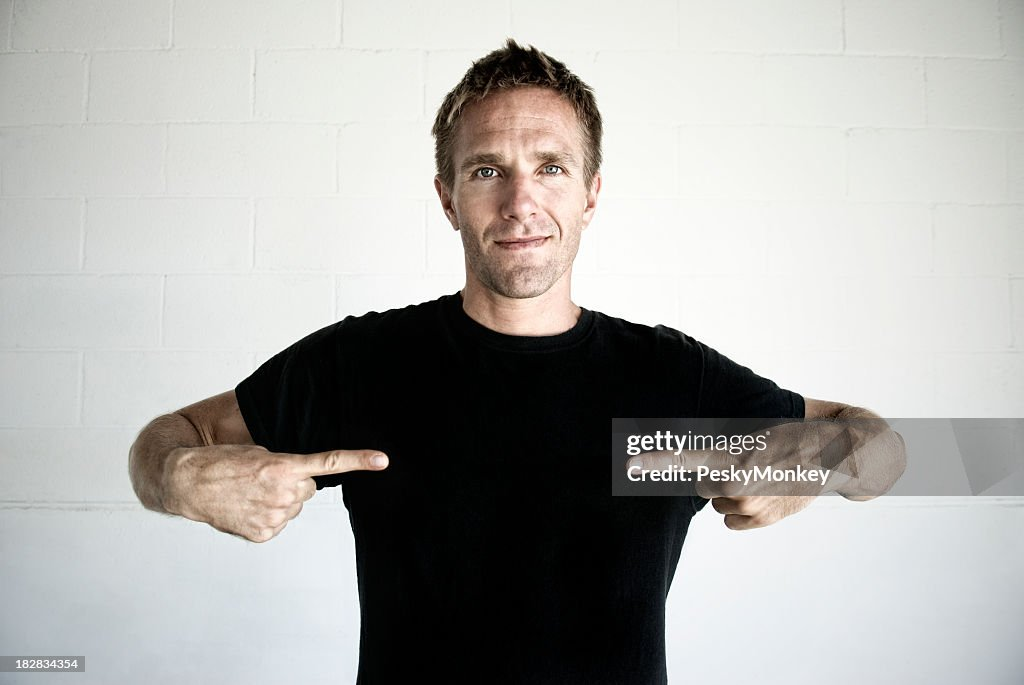What emotions might the man be expressing through his body language? The man's body language, with his direct pointing gesture, upright posture, and half-smile, seems to convey a mix of confidence and approachability. His expression is neither overwhelmingly joyful nor solemn, which could indicate he's calmly asserting a point or sharing information about himself in a positive light. Is there something significant about the setting he is in? The setting appears to be simple and uncluttered, with a plain white wall in the background. This minimalistic background helps keep the focus on the man and his gesture. It doesn’t reveal a specific location, but it suggests an environment that is informal and versatile, perhaps suited for casual presentations, small group gatherings, or photo sessions meant to highlight the individual without distraction. 